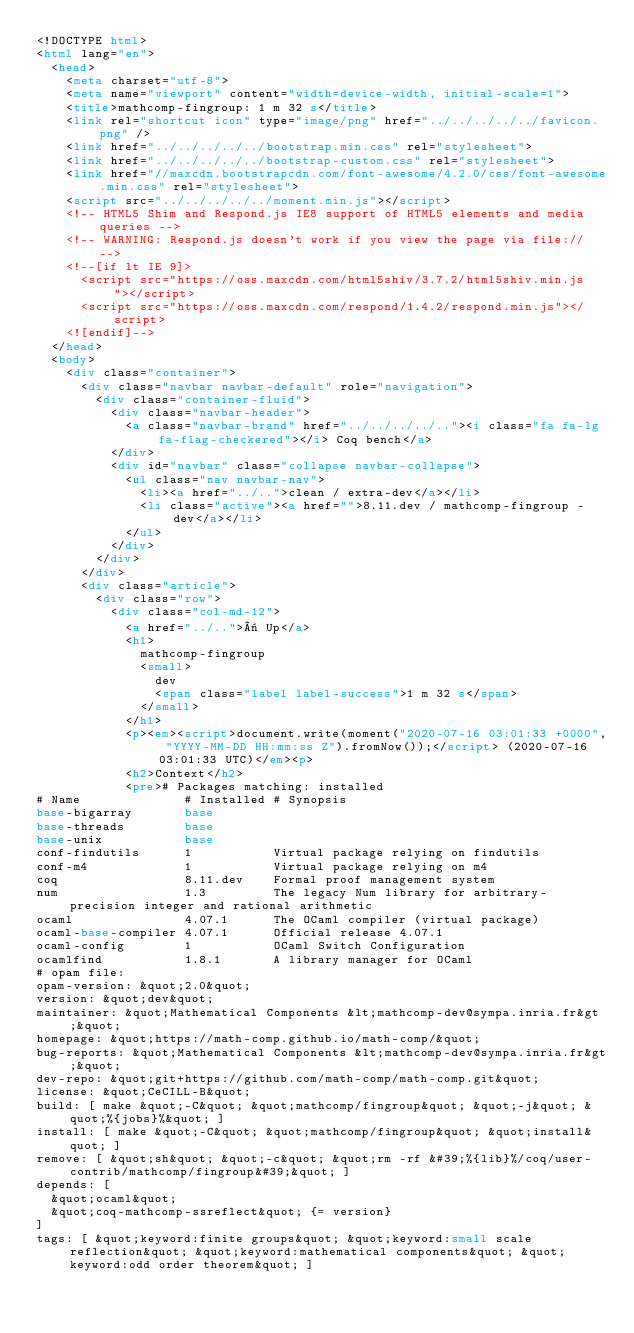Convert code to text. <code><loc_0><loc_0><loc_500><loc_500><_HTML_><!DOCTYPE html>
<html lang="en">
  <head>
    <meta charset="utf-8">
    <meta name="viewport" content="width=device-width, initial-scale=1">
    <title>mathcomp-fingroup: 1 m 32 s</title>
    <link rel="shortcut icon" type="image/png" href="../../../../../favicon.png" />
    <link href="../../../../../bootstrap.min.css" rel="stylesheet">
    <link href="../../../../../bootstrap-custom.css" rel="stylesheet">
    <link href="//maxcdn.bootstrapcdn.com/font-awesome/4.2.0/css/font-awesome.min.css" rel="stylesheet">
    <script src="../../../../../moment.min.js"></script>
    <!-- HTML5 Shim and Respond.js IE8 support of HTML5 elements and media queries -->
    <!-- WARNING: Respond.js doesn't work if you view the page via file:// -->
    <!--[if lt IE 9]>
      <script src="https://oss.maxcdn.com/html5shiv/3.7.2/html5shiv.min.js"></script>
      <script src="https://oss.maxcdn.com/respond/1.4.2/respond.min.js"></script>
    <![endif]-->
  </head>
  <body>
    <div class="container">
      <div class="navbar navbar-default" role="navigation">
        <div class="container-fluid">
          <div class="navbar-header">
            <a class="navbar-brand" href="../../../../.."><i class="fa fa-lg fa-flag-checkered"></i> Coq bench</a>
          </div>
          <div id="navbar" class="collapse navbar-collapse">
            <ul class="nav navbar-nav">
              <li><a href="../..">clean / extra-dev</a></li>
              <li class="active"><a href="">8.11.dev / mathcomp-fingroup - dev</a></li>
            </ul>
          </div>
        </div>
      </div>
      <div class="article">
        <div class="row">
          <div class="col-md-12">
            <a href="../..">« Up</a>
            <h1>
              mathcomp-fingroup
              <small>
                dev
                <span class="label label-success">1 m 32 s</span>
              </small>
            </h1>
            <p><em><script>document.write(moment("2020-07-16 03:01:33 +0000", "YYYY-MM-DD HH:mm:ss Z").fromNow());</script> (2020-07-16 03:01:33 UTC)</em><p>
            <h2>Context</h2>
            <pre># Packages matching: installed
# Name              # Installed # Synopsis
base-bigarray       base
base-threads        base
base-unix           base
conf-findutils      1           Virtual package relying on findutils
conf-m4             1           Virtual package relying on m4
coq                 8.11.dev    Formal proof management system
num                 1.3         The legacy Num library for arbitrary-precision integer and rational arithmetic
ocaml               4.07.1      The OCaml compiler (virtual package)
ocaml-base-compiler 4.07.1      Official release 4.07.1
ocaml-config        1           OCaml Switch Configuration
ocamlfind           1.8.1       A library manager for OCaml
# opam file:
opam-version: &quot;2.0&quot;
version: &quot;dev&quot;
maintainer: &quot;Mathematical Components &lt;mathcomp-dev@sympa.inria.fr&gt;&quot;
homepage: &quot;https://math-comp.github.io/math-comp/&quot;
bug-reports: &quot;Mathematical Components &lt;mathcomp-dev@sympa.inria.fr&gt;&quot;
dev-repo: &quot;git+https://github.com/math-comp/math-comp.git&quot;
license: &quot;CeCILL-B&quot;
build: [ make &quot;-C&quot; &quot;mathcomp/fingroup&quot; &quot;-j&quot; &quot;%{jobs}%&quot; ]
install: [ make &quot;-C&quot; &quot;mathcomp/fingroup&quot; &quot;install&quot; ]
remove: [ &quot;sh&quot; &quot;-c&quot; &quot;rm -rf &#39;%{lib}%/coq/user-contrib/mathcomp/fingroup&#39;&quot; ]
depends: [
  &quot;ocaml&quot;
  &quot;coq-mathcomp-ssreflect&quot; {= version}
]
tags: [ &quot;keyword:finite groups&quot; &quot;keyword:small scale reflection&quot; &quot;keyword:mathematical components&quot; &quot;keyword:odd order theorem&quot; ]</code> 